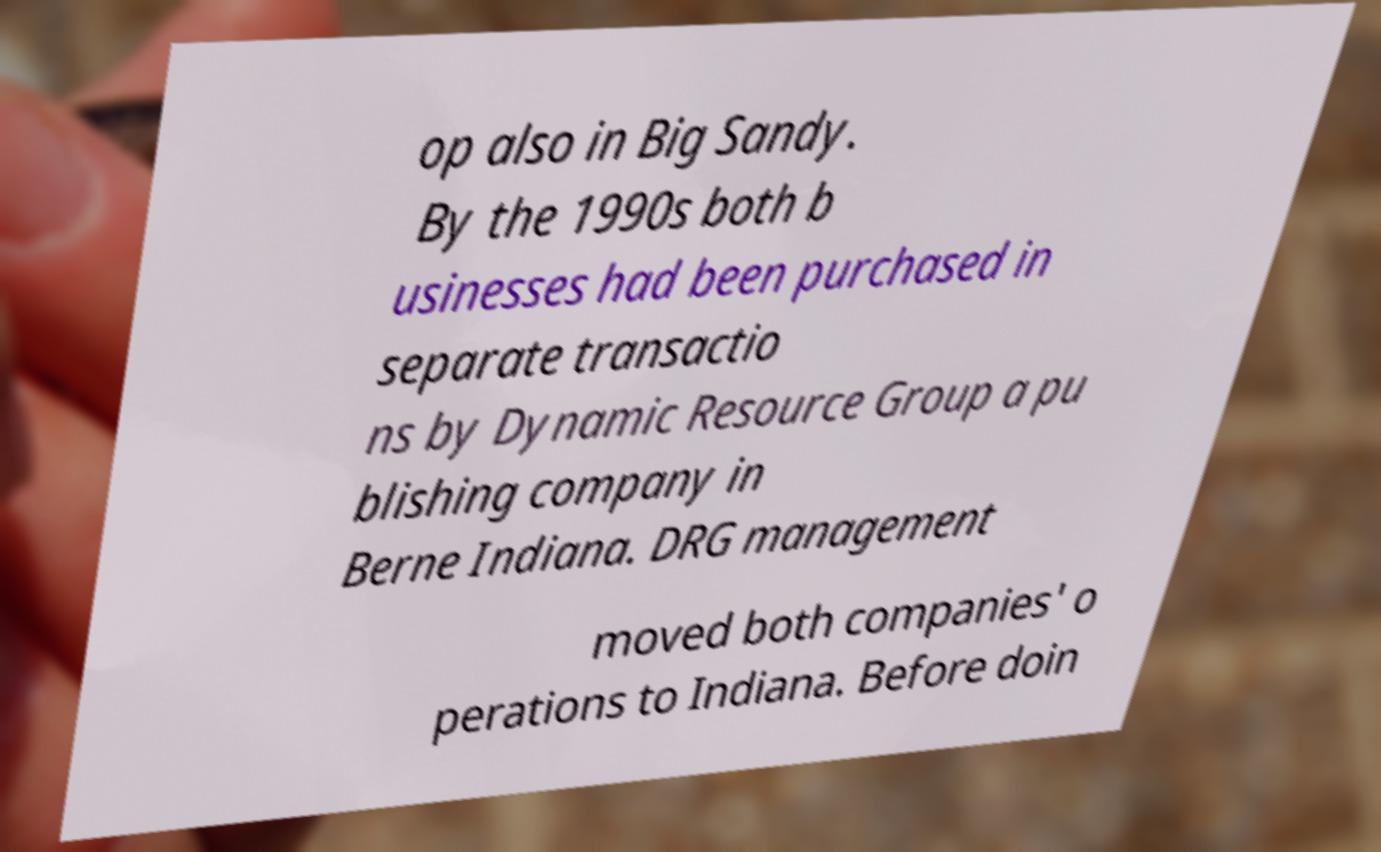For documentation purposes, I need the text within this image transcribed. Could you provide that? op also in Big Sandy. By the 1990s both b usinesses had been purchased in separate transactio ns by Dynamic Resource Group a pu blishing company in Berne Indiana. DRG management moved both companies' o perations to Indiana. Before doin 